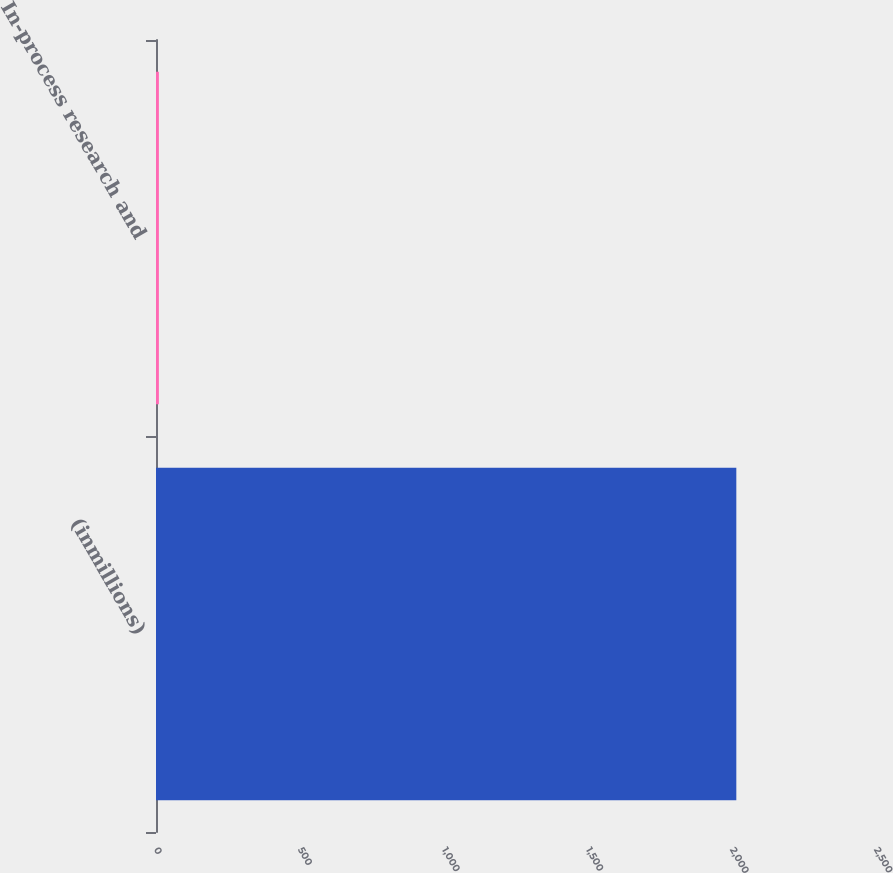Convert chart. <chart><loc_0><loc_0><loc_500><loc_500><bar_chart><fcel>(inmillions)<fcel>In-process research and<nl><fcel>2015<fcel>10<nl></chart> 